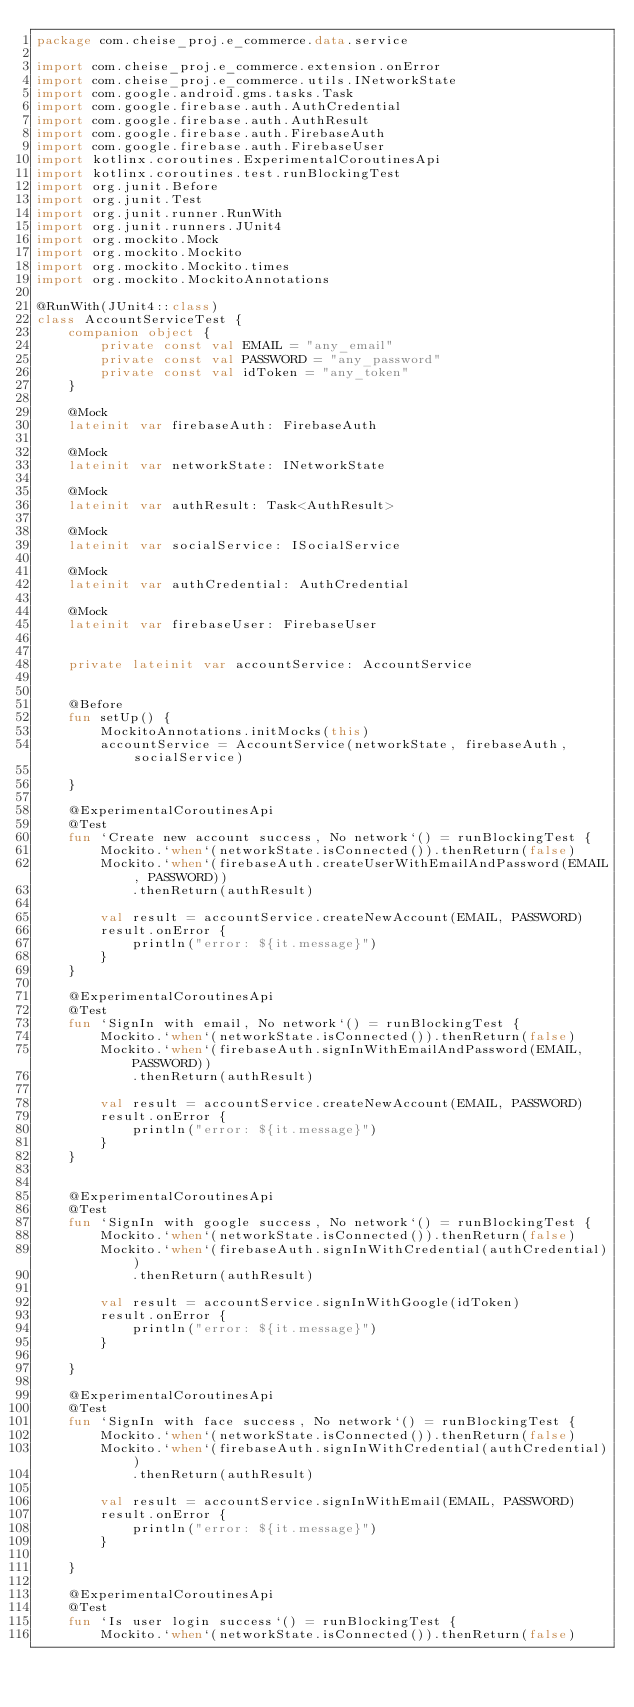Convert code to text. <code><loc_0><loc_0><loc_500><loc_500><_Kotlin_>package com.cheise_proj.e_commerce.data.service

import com.cheise_proj.e_commerce.extension.onError
import com.cheise_proj.e_commerce.utils.INetworkState
import com.google.android.gms.tasks.Task
import com.google.firebase.auth.AuthCredential
import com.google.firebase.auth.AuthResult
import com.google.firebase.auth.FirebaseAuth
import com.google.firebase.auth.FirebaseUser
import kotlinx.coroutines.ExperimentalCoroutinesApi
import kotlinx.coroutines.test.runBlockingTest
import org.junit.Before
import org.junit.Test
import org.junit.runner.RunWith
import org.junit.runners.JUnit4
import org.mockito.Mock
import org.mockito.Mockito
import org.mockito.Mockito.times
import org.mockito.MockitoAnnotations

@RunWith(JUnit4::class)
class AccountServiceTest {
    companion object {
        private const val EMAIL = "any_email"
        private const val PASSWORD = "any_password"
        private const val idToken = "any_token"
    }

    @Mock
    lateinit var firebaseAuth: FirebaseAuth

    @Mock
    lateinit var networkState: INetworkState

    @Mock
    lateinit var authResult: Task<AuthResult>

    @Mock
    lateinit var socialService: ISocialService

    @Mock
    lateinit var authCredential: AuthCredential

    @Mock
    lateinit var firebaseUser: FirebaseUser


    private lateinit var accountService: AccountService


    @Before
    fun setUp() {
        MockitoAnnotations.initMocks(this)
        accountService = AccountService(networkState, firebaseAuth, socialService)

    }

    @ExperimentalCoroutinesApi
    @Test
    fun `Create new account success, No network`() = runBlockingTest {
        Mockito.`when`(networkState.isConnected()).thenReturn(false)
        Mockito.`when`(firebaseAuth.createUserWithEmailAndPassword(EMAIL, PASSWORD))
            .thenReturn(authResult)

        val result = accountService.createNewAccount(EMAIL, PASSWORD)
        result.onError {
            println("error: ${it.message}")
        }
    }

    @ExperimentalCoroutinesApi
    @Test
    fun `SignIn with email, No network`() = runBlockingTest {
        Mockito.`when`(networkState.isConnected()).thenReturn(false)
        Mockito.`when`(firebaseAuth.signInWithEmailAndPassword(EMAIL, PASSWORD))
            .thenReturn(authResult)

        val result = accountService.createNewAccount(EMAIL, PASSWORD)
        result.onError {
            println("error: ${it.message}")
        }
    }


    @ExperimentalCoroutinesApi
    @Test
    fun `SignIn with google success, No network`() = runBlockingTest {
        Mockito.`when`(networkState.isConnected()).thenReturn(false)
        Mockito.`when`(firebaseAuth.signInWithCredential(authCredential))
            .thenReturn(authResult)

        val result = accountService.signInWithGoogle(idToken)
        result.onError {
            println("error: ${it.message}")
        }

    }

    @ExperimentalCoroutinesApi
    @Test
    fun `SignIn with face success, No network`() = runBlockingTest {
        Mockito.`when`(networkState.isConnected()).thenReturn(false)
        Mockito.`when`(firebaseAuth.signInWithCredential(authCredential))
            .thenReturn(authResult)

        val result = accountService.signInWithEmail(EMAIL, PASSWORD)
        result.onError {
            println("error: ${it.message}")
        }

    }

    @ExperimentalCoroutinesApi
    @Test
    fun `Is user login success`() = runBlockingTest {
        Mockito.`when`(networkState.isConnected()).thenReturn(false)</code> 